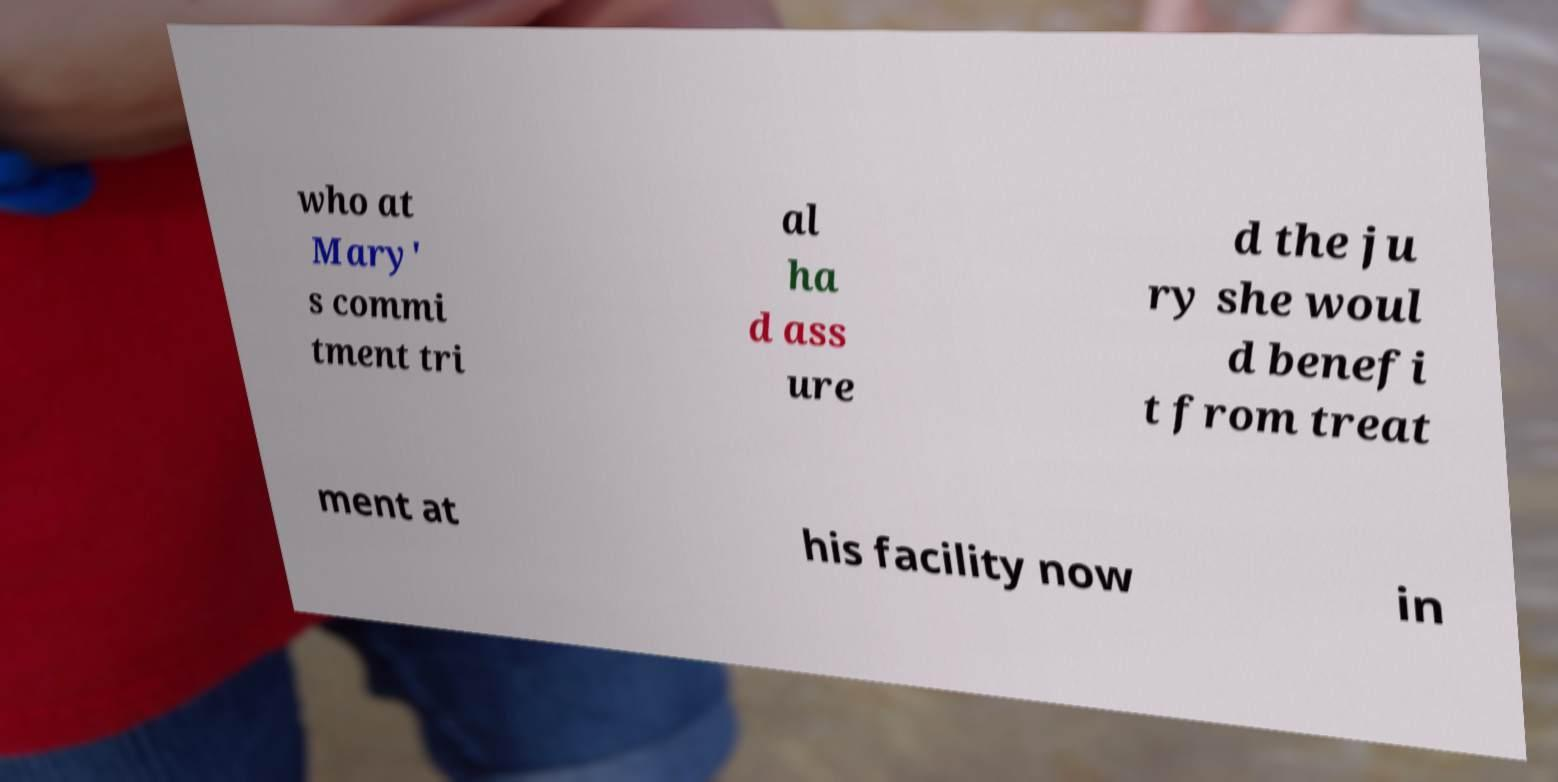Please identify and transcribe the text found in this image. who at Mary' s commi tment tri al ha d ass ure d the ju ry she woul d benefi t from treat ment at his facility now in 